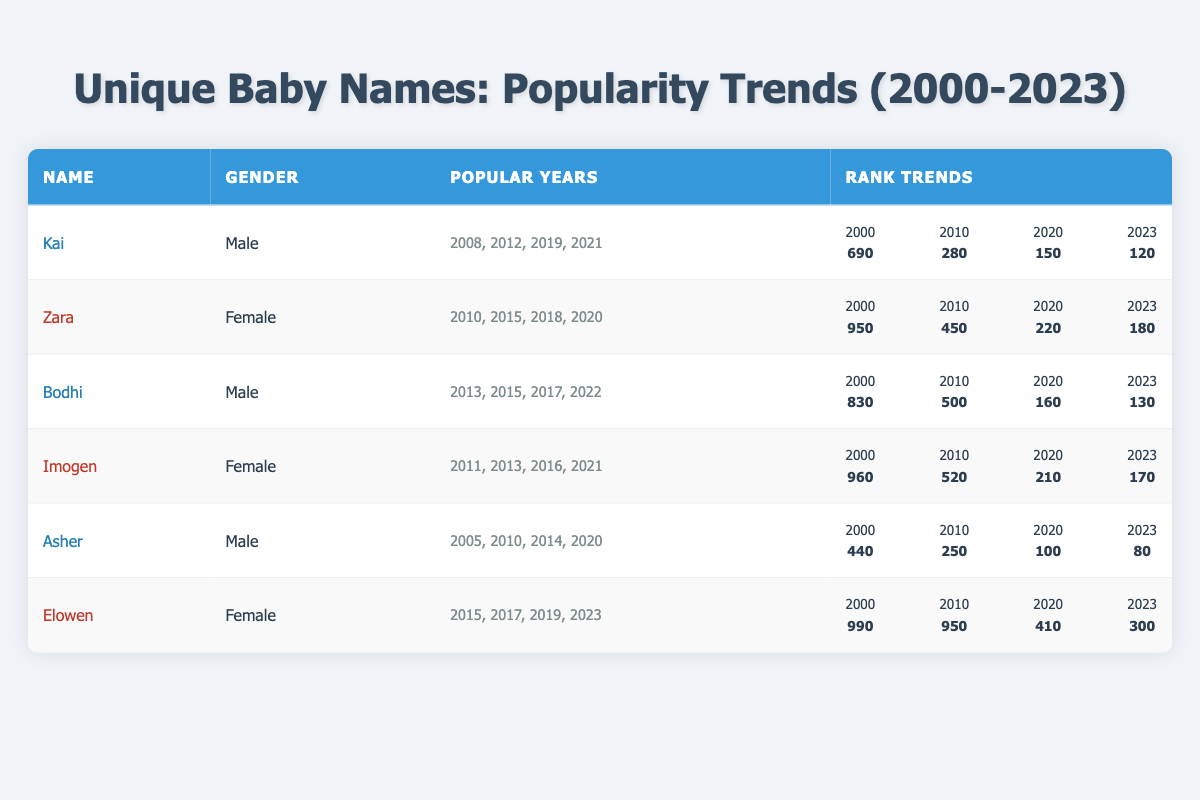What is the rank of the name "Imogen" in 2023? The table shows the rank of "Imogen" for each year. In the "rank" column for the year 2023, "Imogen" is listed with a rank of 170.
Answer: 170 Which unique baby name had the highest rank in 2000? By looking at the rank data for all names in 2000, "Elowen" had the highest rank at 990, as it is the lowest on the ranking scale (the higher the number, the lower the rank).
Answer: Elowen Was the name "Asher" ever ranked higher than 100 in 2010? In the table, the rank for "Asher" in 2010 is listed as 250, which is indeed higher than 100. Therefore, the statement is true.
Answer: Yes Calculate the average rank of the name "Bodhi" over the available years. Summing Bodhi's ranks: 830 (2000) + 500 (2010) + 240 (2015) + 160 (2020) + 130 (2023) gives 1860. Dividing by the number of years (5) results in an average rank of 372.
Answer: 372 In which year did the name "Zara" have its lowest rank? The ranks for "Zara" across the years are: 950 (2000), 450 (2010), 350 (2015), 220 (2020), and 180 (2023). The lowest rank (best popularity) occurs in 2023 with a rank of 180.
Answer: 2023 How many unique baby names had a rank lower than 150 in 2023? The ranks for 2023 show that "Kai" (120), "Bodhi" (130), "Asher" (80), and "Zara" (180) had ranks below 150. Therefore, out of the 6 names, 3 names had this rank condition.
Answer: 3 Is the name "Elowen" listed among the popular names in 2015? Yes, the table indicates that "Elowen" is listed among the popular names for 2015, confirming that it was a popular name during that year.
Answer: Yes Which name had the most consistent rank improvement over the years? Analyzing ranks shows that "Asher" improved consistently over the years, starting at 440 in 2000 to 80 in 2023. This consistent downward trend reflects a clear improvement.
Answer: Asher 